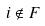Convert formula to latex. <formula><loc_0><loc_0><loc_500><loc_500>i \notin F</formula> 